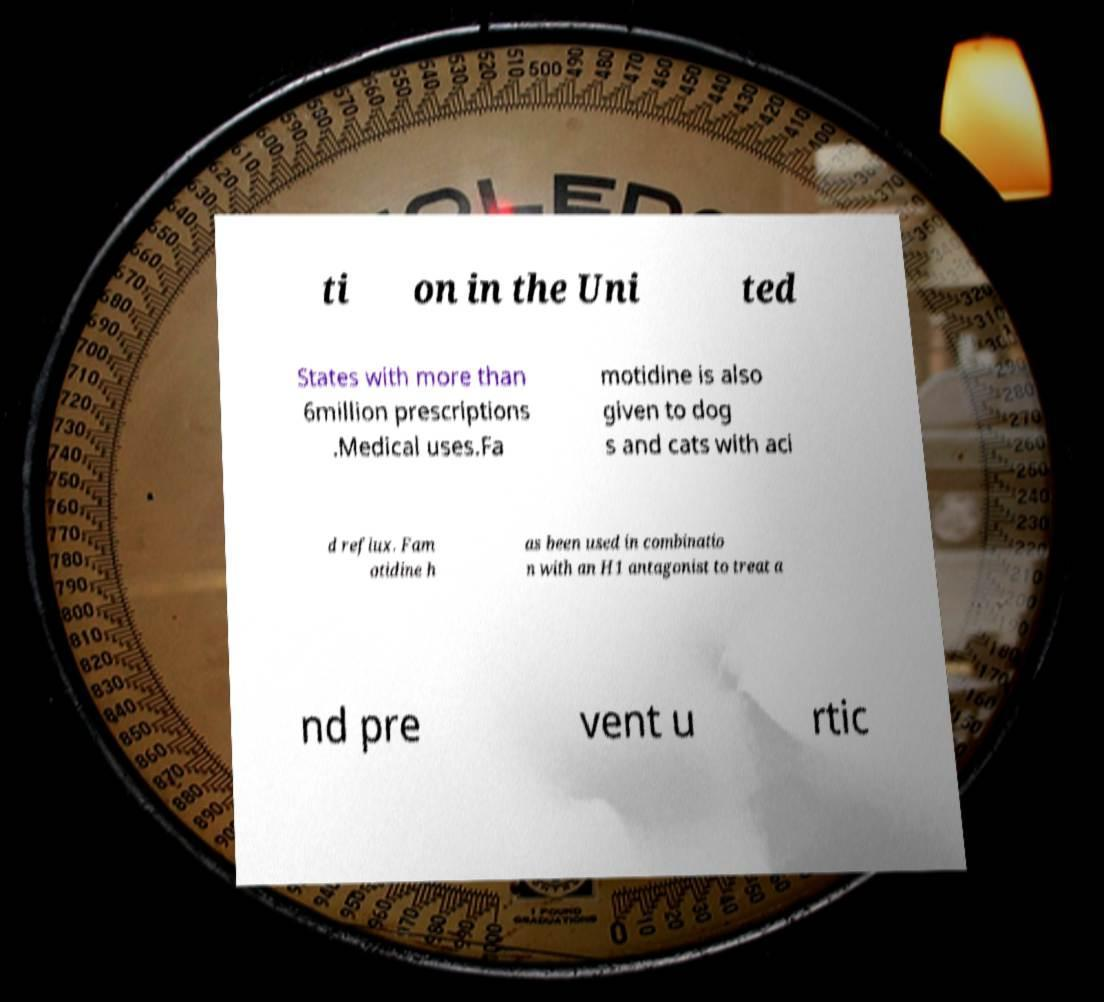What messages or text are displayed in this image? I need them in a readable, typed format. ti on in the Uni ted States with more than 6million prescriptions .Medical uses.Fa motidine is also given to dog s and cats with aci d reflux. Fam otidine h as been used in combinatio n with an H1 antagonist to treat a nd pre vent u rtic 